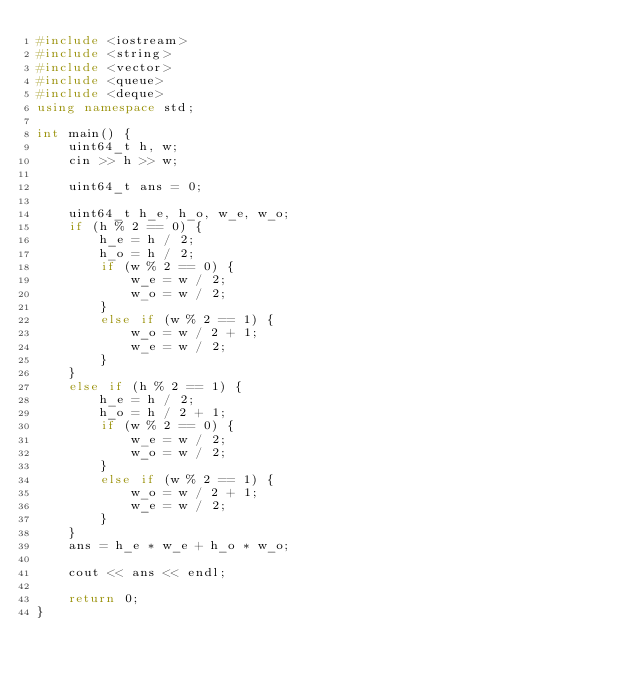Convert code to text. <code><loc_0><loc_0><loc_500><loc_500><_C++_>#include <iostream>
#include <string>
#include <vector>
#include <queue>
#include <deque>
using namespace std;

int main() {
	uint64_t h, w;
	cin >> h >> w;

	uint64_t ans = 0;

	uint64_t h_e, h_o, w_e, w_o;
	if (h % 2 == 0) {
		h_e = h / 2;
		h_o = h / 2;
		if (w % 2 == 0) {
			w_e = w / 2;
			w_o = w / 2;
		}
		else if (w % 2 == 1) {
			w_o = w / 2 + 1;
			w_e = w / 2;
		}
	}
	else if (h % 2 == 1) {
		h_e = h / 2;
		h_o = h / 2 + 1;
		if (w % 2 == 0) {
			w_e = w / 2;
			w_o = w / 2;
		}
		else if (w % 2 == 1) {
			w_o = w / 2 + 1;
			w_e = w / 2;
		}
	}
	ans = h_e * w_e + h_o * w_o;

	cout << ans << endl;

	return 0;
}</code> 